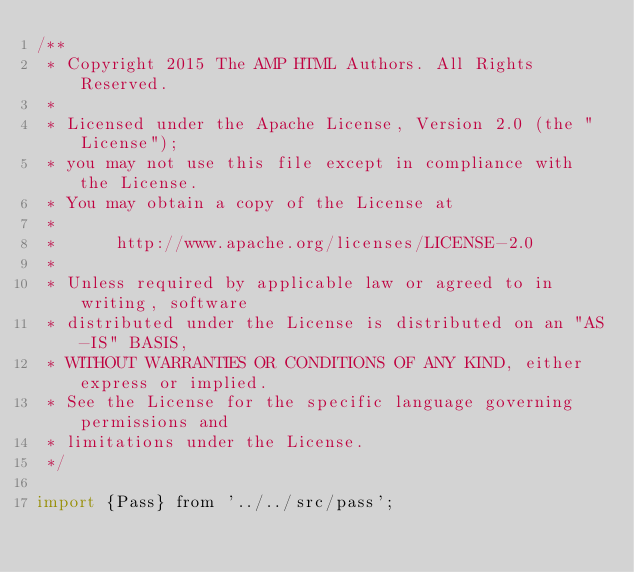<code> <loc_0><loc_0><loc_500><loc_500><_JavaScript_>/**
 * Copyright 2015 The AMP HTML Authors. All Rights Reserved.
 *
 * Licensed under the Apache License, Version 2.0 (the "License");
 * you may not use this file except in compliance with the License.
 * You may obtain a copy of the License at
 *
 *      http://www.apache.org/licenses/LICENSE-2.0
 *
 * Unless required by applicable law or agreed to in writing, software
 * distributed under the License is distributed on an "AS-IS" BASIS,
 * WITHOUT WARRANTIES OR CONDITIONS OF ANY KIND, either express or implied.
 * See the License for the specific language governing permissions and
 * limitations under the License.
 */

import {Pass} from '../../src/pass';</code> 